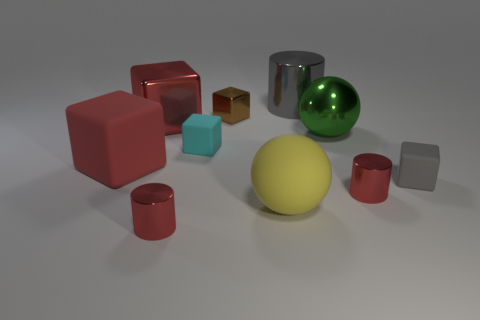Subtract all cyan cubes. How many cubes are left? 4 Subtract all small gray blocks. How many blocks are left? 4 Subtract 2 blocks. How many blocks are left? 3 Subtract all cyan blocks. Subtract all cyan spheres. How many blocks are left? 4 Subtract all spheres. How many objects are left? 8 Add 5 green objects. How many green objects are left? 6 Add 8 green metallic balls. How many green metallic balls exist? 9 Subtract 0 green cylinders. How many objects are left? 10 Subtract all green metallic balls. Subtract all small gray cubes. How many objects are left? 8 